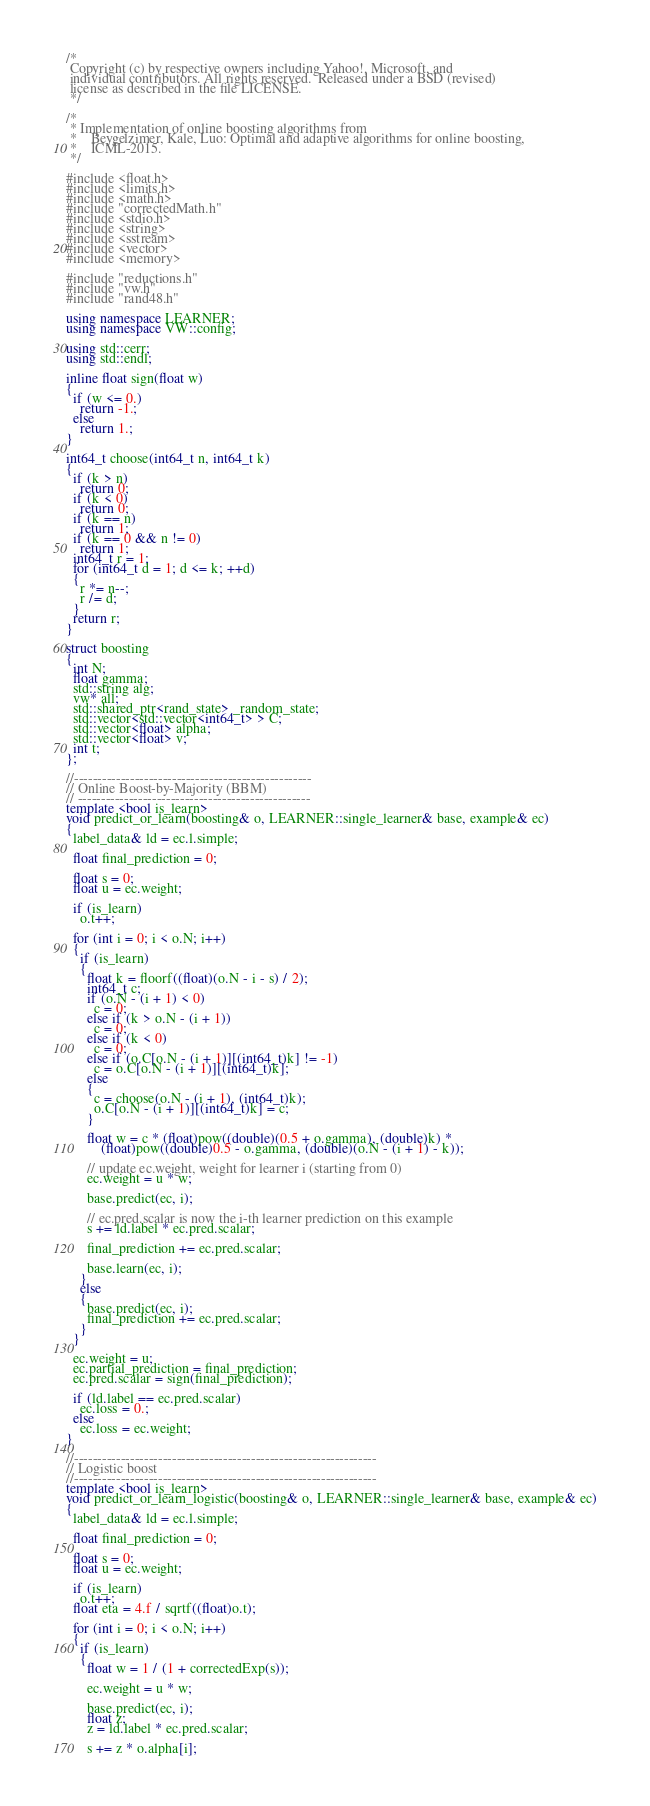<code> <loc_0><loc_0><loc_500><loc_500><_C++_>/*
 Copyright (c) by respective owners including Yahoo!, Microsoft, and
 individual contributors. All rights reserved.  Released under a BSD (revised)
 license as described in the file LICENSE.
 */

/*
 * Implementation of online boosting algorithms from
 *    Beygelzimer, Kale, Luo: Optimal and adaptive algorithms for online boosting,
 *    ICML-2015.
 */

#include <float.h>
#include <limits.h>
#include <math.h>
#include "correctedMath.h"
#include <stdio.h>
#include <string>
#include <sstream>
#include <vector>
#include <memory>

#include "reductions.h"
#include "vw.h"
#include "rand48.h"

using namespace LEARNER;
using namespace VW::config;

using std::cerr;
using std::endl;

inline float sign(float w)
{
  if (w <= 0.)
    return -1.;
  else
    return 1.;
}

int64_t choose(int64_t n, int64_t k)
{
  if (k > n)
    return 0;
  if (k < 0)
    return 0;
  if (k == n)
    return 1;
  if (k == 0 && n != 0)
    return 1;
  int64_t r = 1;
  for (int64_t d = 1; d <= k; ++d)
  {
    r *= n--;
    r /= d;
  }
  return r;
}

struct boosting
{
  int N;
  float gamma;
  std::string alg;
  vw* all;
  std::shared_ptr<rand_state> _random_state;
  std::vector<std::vector<int64_t> > C;
  std::vector<float> alpha;
  std::vector<float> v;
  int t;
};

//---------------------------------------------------
// Online Boost-by-Majority (BBM)
// --------------------------------------------------
template <bool is_learn>
void predict_or_learn(boosting& o, LEARNER::single_learner& base, example& ec)
{
  label_data& ld = ec.l.simple;

  float final_prediction = 0;

  float s = 0;
  float u = ec.weight;

  if (is_learn)
    o.t++;

  for (int i = 0; i < o.N; i++)
  {
    if (is_learn)
    {
      float k = floorf((float)(o.N - i - s) / 2);
      int64_t c;
      if (o.N - (i + 1) < 0)
        c = 0;
      else if (k > o.N - (i + 1))
        c = 0;
      else if (k < 0)
        c = 0;
      else if (o.C[o.N - (i + 1)][(int64_t)k] != -1)
        c = o.C[o.N - (i + 1)][(int64_t)k];
      else
      {
        c = choose(o.N - (i + 1), (int64_t)k);
        o.C[o.N - (i + 1)][(int64_t)k] = c;
      }

      float w = c * (float)pow((double)(0.5 + o.gamma), (double)k) *
          (float)pow((double)0.5 - o.gamma, (double)(o.N - (i + 1) - k));

      // update ec.weight, weight for learner i (starting from 0)
      ec.weight = u * w;

      base.predict(ec, i);

      // ec.pred.scalar is now the i-th learner prediction on this example
      s += ld.label * ec.pred.scalar;

      final_prediction += ec.pred.scalar;

      base.learn(ec, i);
    }
    else
    {
      base.predict(ec, i);
      final_prediction += ec.pred.scalar;
    }
  }

  ec.weight = u;
  ec.partial_prediction = final_prediction;
  ec.pred.scalar = sign(final_prediction);

  if (ld.label == ec.pred.scalar)
    ec.loss = 0.;
  else
    ec.loss = ec.weight;
}

//-----------------------------------------------------------------
// Logistic boost
//-----------------------------------------------------------------
template <bool is_learn>
void predict_or_learn_logistic(boosting& o, LEARNER::single_learner& base, example& ec)
{
  label_data& ld = ec.l.simple;

  float final_prediction = 0;

  float s = 0;
  float u = ec.weight;

  if (is_learn)
    o.t++;
  float eta = 4.f / sqrtf((float)o.t);

  for (int i = 0; i < o.N; i++)
  {
    if (is_learn)
    {
      float w = 1 / (1 + correctedExp(s));

      ec.weight = u * w;

      base.predict(ec, i);
      float z;
      z = ld.label * ec.pred.scalar;

      s += z * o.alpha[i];
</code> 